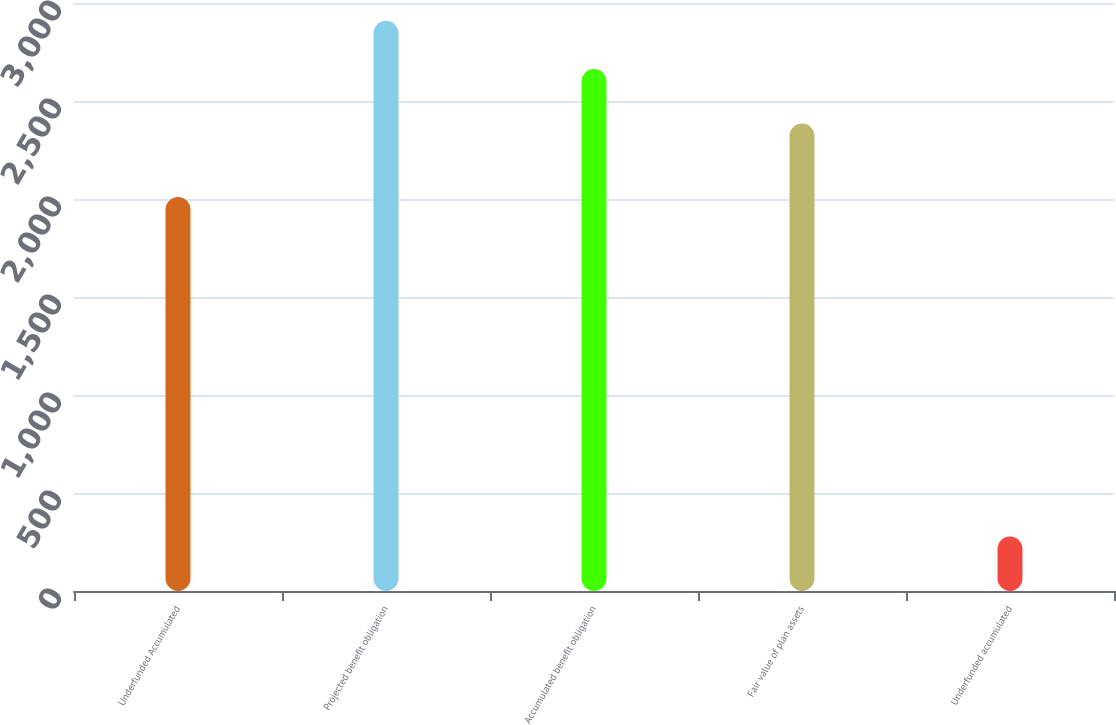Convert chart to OTSL. <chart><loc_0><loc_0><loc_500><loc_500><bar_chart><fcel>Underfunded Accumulated<fcel>Projected benefit obligation<fcel>Accumulated benefit obligation<fcel>Fair value of plan assets<fcel>Underfunded accumulated<nl><fcel>2010<fcel>2909.3<fcel>2663<fcel>2385<fcel>278<nl></chart> 